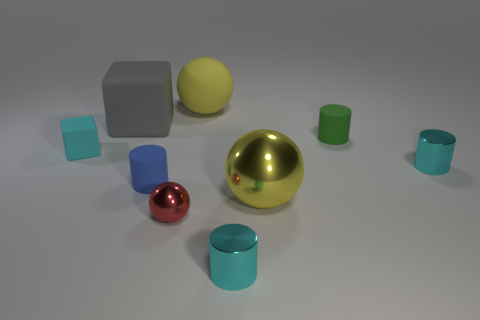Are there any patterns or themes in the arrangement of these objects? The arrangement of objects in the image doesn't seem to follow any obvious pattern, but there is a theme of basic geometric shapes represented. The objects include spheres, cylinders, and cubes, each with different sizes and colors, offering a study in geometry and contrast. 